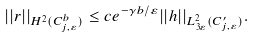Convert formula to latex. <formula><loc_0><loc_0><loc_500><loc_500>| | r | | _ { H ^ { 2 } ( C _ { j , \varepsilon } ^ { b } ) } \leq c e ^ { - \gamma b / \varepsilon } | | h | | _ { L _ { 3 \varepsilon } ^ { 2 } ( C _ { j , \varepsilon } ^ { \prime } ) } .</formula> 